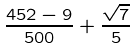Convert formula to latex. <formula><loc_0><loc_0><loc_500><loc_500>\frac { 4 5 2 - 9 } { 5 0 0 } + \frac { \sqrt { 7 } } { 5 }</formula> 